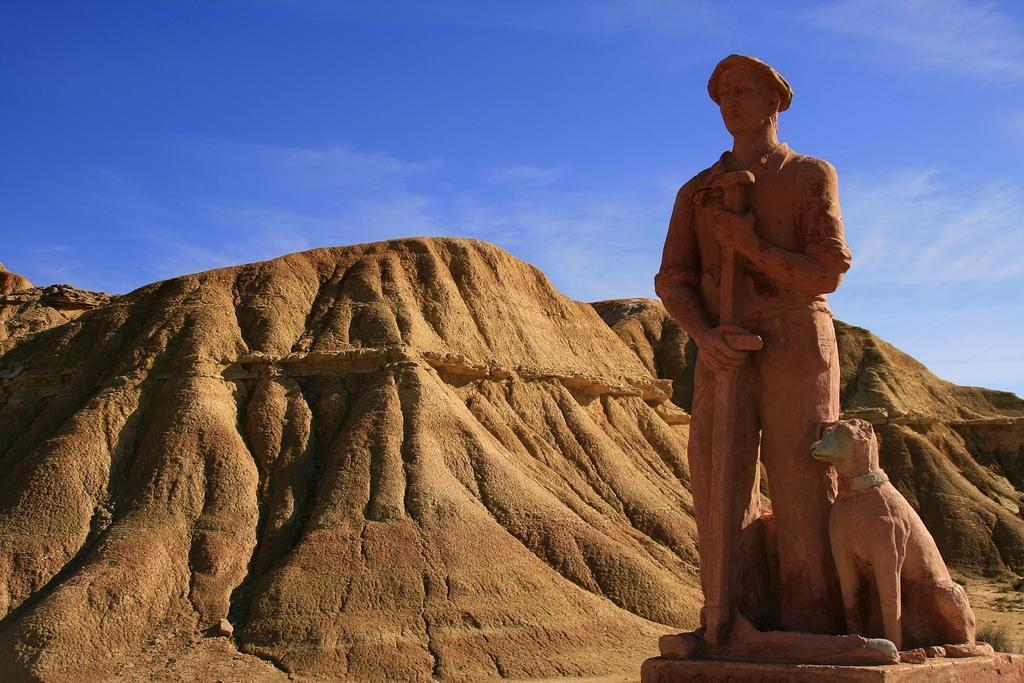Could you give a brief overview of what you see in this image? In this image I can see the statue of the person and the dog. In the background I can see the mountains, clouds and the blue sky. 